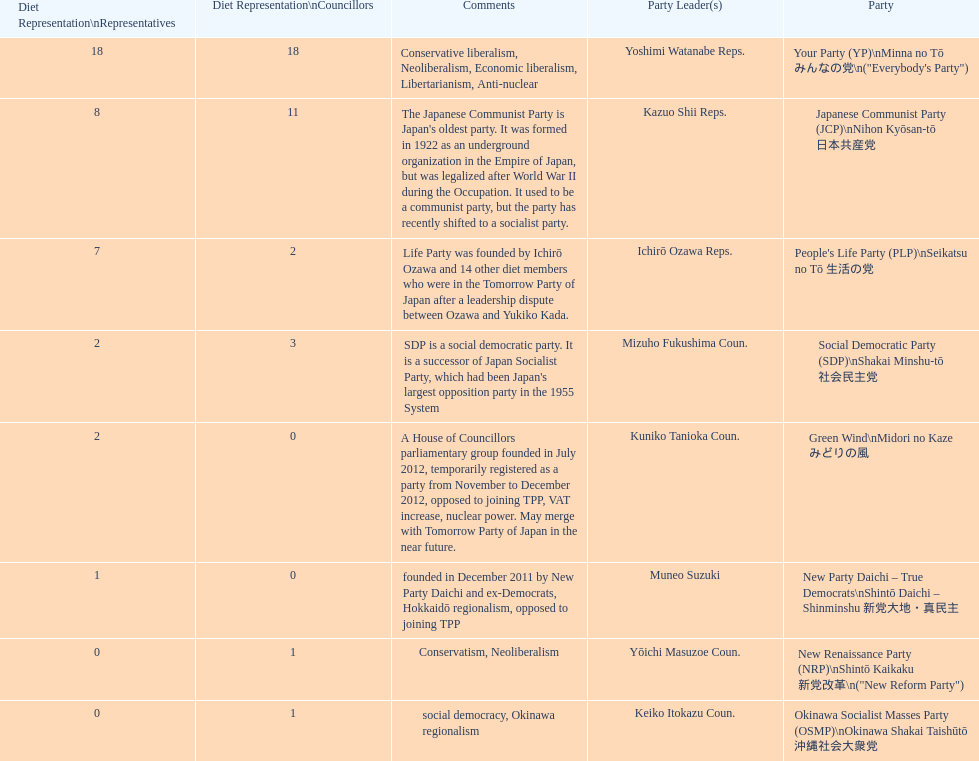What party has the most representatives in the diet representation? Your Party. 